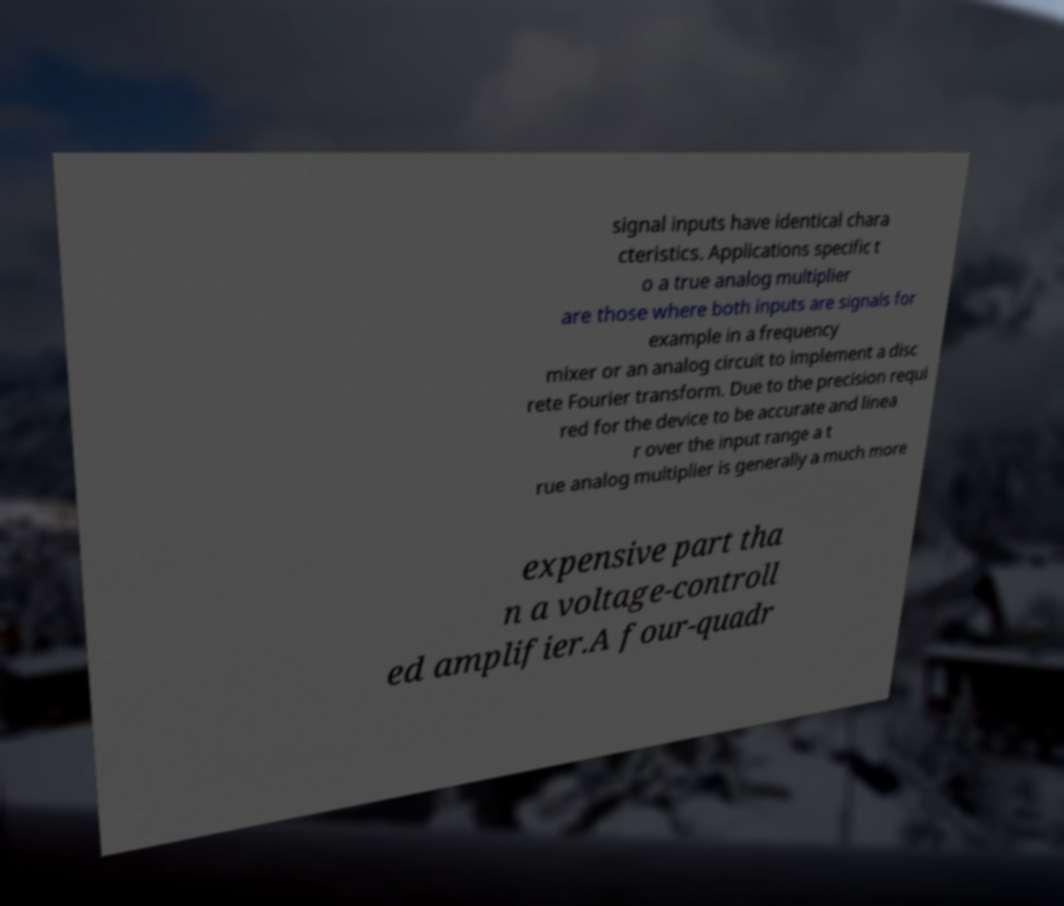I need the written content from this picture converted into text. Can you do that? signal inputs have identical chara cteristics. Applications specific t o a true analog multiplier are those where both inputs are signals for example in a frequency mixer or an analog circuit to implement a disc rete Fourier transform. Due to the precision requi red for the device to be accurate and linea r over the input range a t rue analog multiplier is generally a much more expensive part tha n a voltage-controll ed amplifier.A four-quadr 